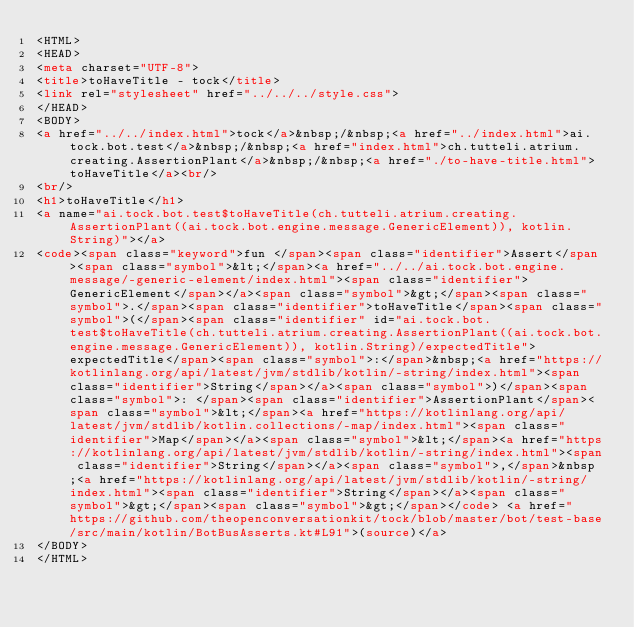<code> <loc_0><loc_0><loc_500><loc_500><_HTML_><HTML>
<HEAD>
<meta charset="UTF-8">
<title>toHaveTitle - tock</title>
<link rel="stylesheet" href="../../../style.css">
</HEAD>
<BODY>
<a href="../../index.html">tock</a>&nbsp;/&nbsp;<a href="../index.html">ai.tock.bot.test</a>&nbsp;/&nbsp;<a href="index.html">ch.tutteli.atrium.creating.AssertionPlant</a>&nbsp;/&nbsp;<a href="./to-have-title.html">toHaveTitle</a><br/>
<br/>
<h1>toHaveTitle</h1>
<a name="ai.tock.bot.test$toHaveTitle(ch.tutteli.atrium.creating.AssertionPlant((ai.tock.bot.engine.message.GenericElement)), kotlin.String)"></a>
<code><span class="keyword">fun </span><span class="identifier">Assert</span><span class="symbol">&lt;</span><a href="../../ai.tock.bot.engine.message/-generic-element/index.html"><span class="identifier">GenericElement</span></a><span class="symbol">&gt;</span><span class="symbol">.</span><span class="identifier">toHaveTitle</span><span class="symbol">(</span><span class="identifier" id="ai.tock.bot.test$toHaveTitle(ch.tutteli.atrium.creating.AssertionPlant((ai.tock.bot.engine.message.GenericElement)), kotlin.String)/expectedTitle">expectedTitle</span><span class="symbol">:</span>&nbsp;<a href="https://kotlinlang.org/api/latest/jvm/stdlib/kotlin/-string/index.html"><span class="identifier">String</span></a><span class="symbol">)</span><span class="symbol">: </span><span class="identifier">AssertionPlant</span><span class="symbol">&lt;</span><a href="https://kotlinlang.org/api/latest/jvm/stdlib/kotlin.collections/-map/index.html"><span class="identifier">Map</span></a><span class="symbol">&lt;</span><a href="https://kotlinlang.org/api/latest/jvm/stdlib/kotlin/-string/index.html"><span class="identifier">String</span></a><span class="symbol">,</span>&nbsp;<a href="https://kotlinlang.org/api/latest/jvm/stdlib/kotlin/-string/index.html"><span class="identifier">String</span></a><span class="symbol">&gt;</span><span class="symbol">&gt;</span></code> <a href="https://github.com/theopenconversationkit/tock/blob/master/bot/test-base/src/main/kotlin/BotBusAsserts.kt#L91">(source)</a>
</BODY>
</HTML>
</code> 